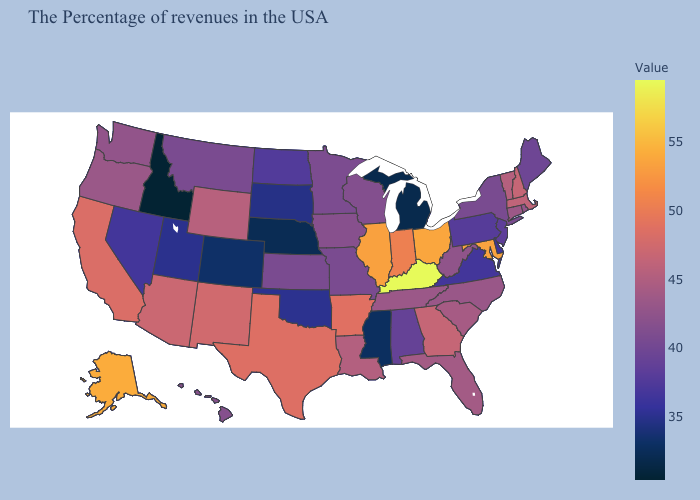Does New Hampshire have the highest value in the Northeast?
Short answer required. Yes. Does the map have missing data?
Be succinct. No. Does Pennsylvania have the lowest value in the Northeast?
Keep it brief. Yes. Does Idaho have the lowest value in the USA?
Short answer required. Yes. Which states have the highest value in the USA?
Quick response, please. Kentucky. Which states have the lowest value in the USA?
Quick response, please. Idaho. Which states hav the highest value in the West?
Be succinct. Alaska. 